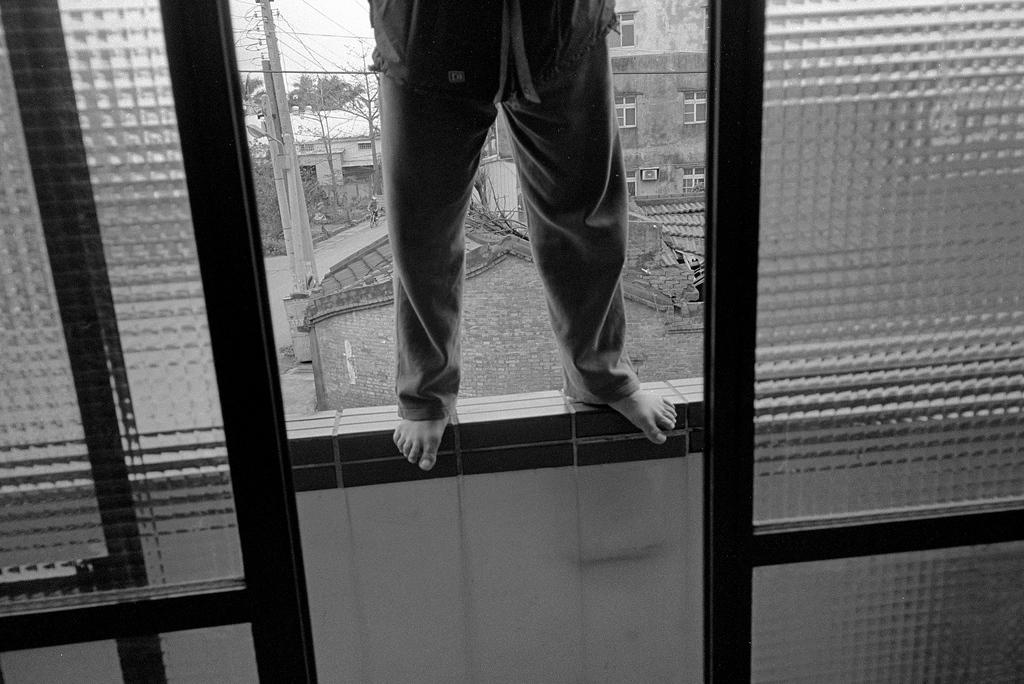What is the person in the image doing? The person is standing on a wall in the image. What can be seen in the background of the image? There are houses, poles, cables, and trees in the background of the image. What type of iron is being used by the person in the image? There is no iron present in the image; the person is standing on a wall. What kind of birds can be seen flying in the image? There are no birds visible in the image. 